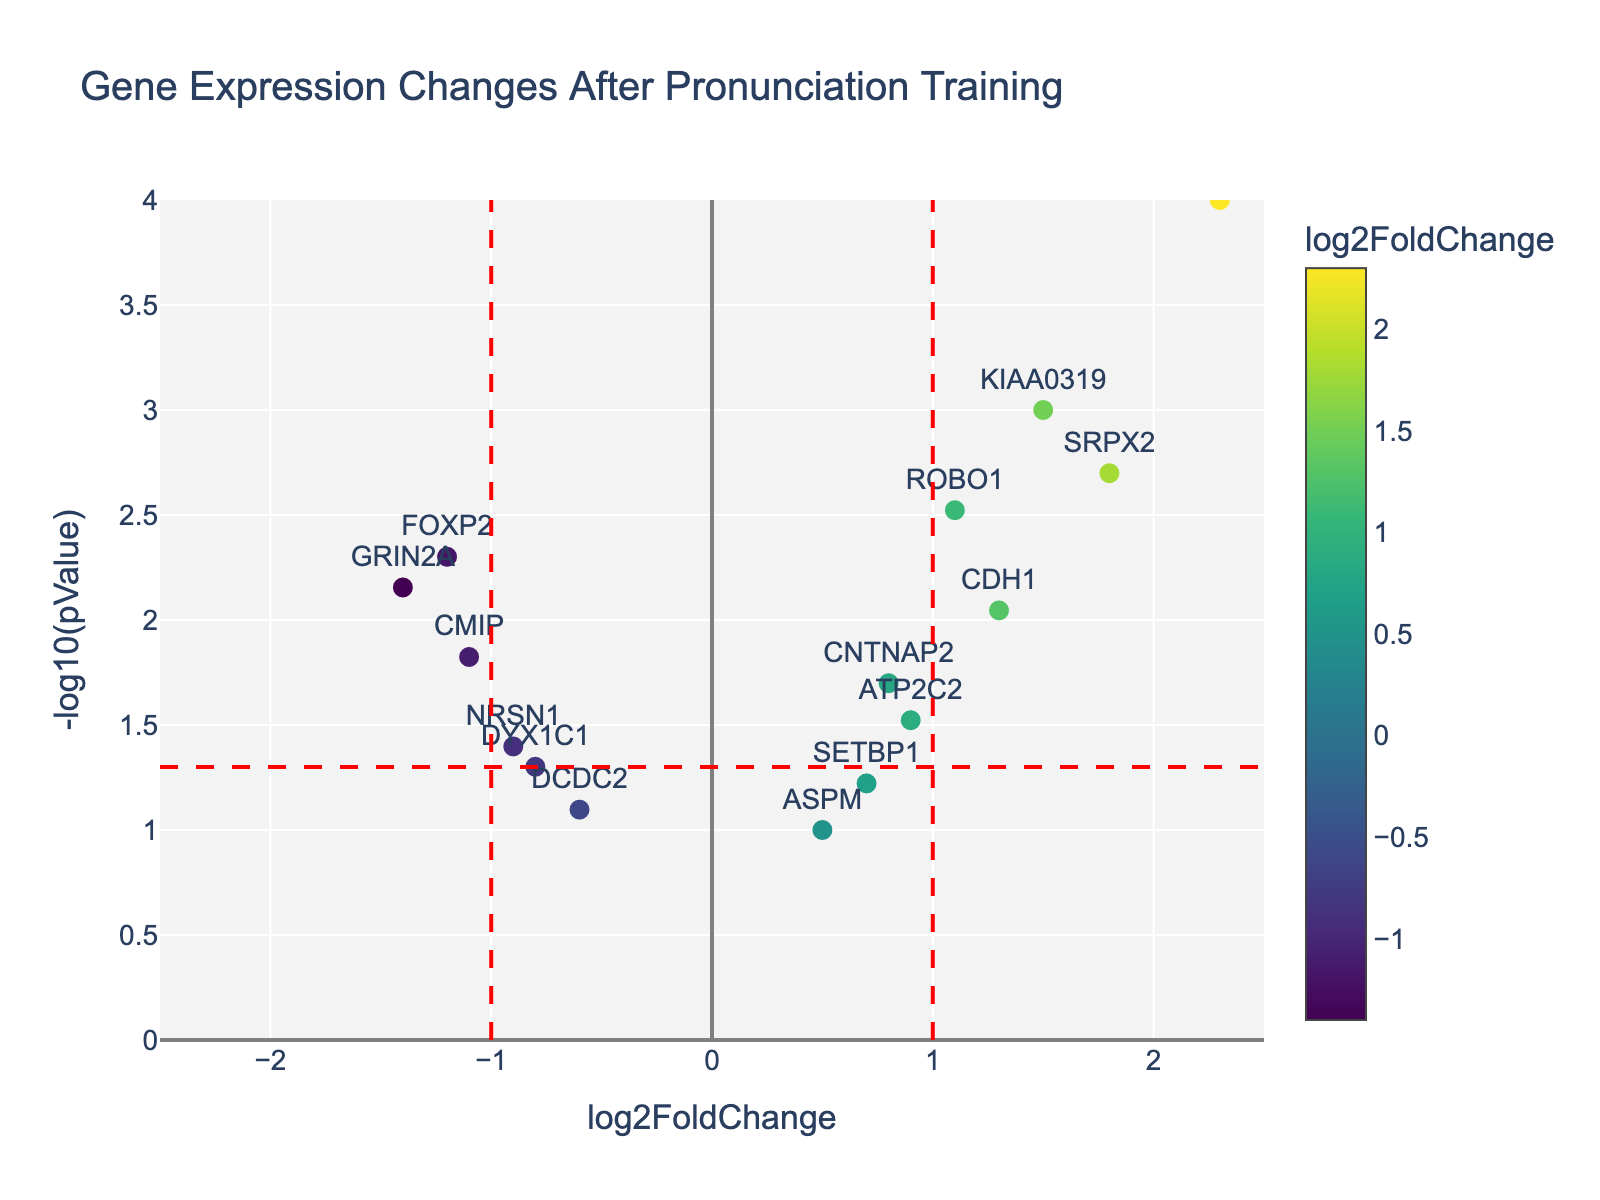How many genes are represented in the plot? Count each unique gene labeled on the plot. There are 15 unique genes shown.
Answer: 15 What does the x-axis represent? The x-axis is labeled 'log2FoldChange,' which indicates the change in gene expression on a log2 scale before and after pronunciation training.
Answer: log2FoldChange Which gene has the highest log2FoldChange? Identify the gene with the highest position on the x-axis. BDNF has the highest log2FoldChange at 2.3.
Answer: BDNF Which genes have a significant p-value below 0.01? Look for genes where the -log10(pValue) is greater than 2, indicating p-values below 0.01. The genes are FOXP2, KIAA0319, ROBO1, SRPX2, GRIN2A, CDH1, and CMIP.
Answer: FOXP2, KIAA0319, ROBO1, SRPX2, GRIN2A, CDH1, CMIP What's the significance threshold for the -log10(pValue)? The horizontal red dashed line intersects the y-axis at 1.3, indicating the threshold for significance.
Answer: 1.3 Which gene shows the largest negative log2FoldChange? Identify the gene with the most leftward position on the x-axis. GRIN2A has the largest negative log2FoldChange at -1.4.
Answer: GRIN2A How many genes have both log2FoldChange values above 1 and significant p-values? Look at genes to the right of the x=1 line and above the y=1.3 line. These genes are KIAA0319, ROBO1, SRPX2, and CDH1.
Answer: 4 Which gene has a log2FoldChange closest to 0.8 and what is its p-value? Look for the gene near the x-axis value of 0.8. The gene is CNTNAP2, which has a p-value of 0.02.
Answer: CNTNAP2, 0.02 What is the p-value range represented in the plot? The range of p-values can be observed from the highest and lowest -log10(pValue) values. The highest -log10(pValue) is 4 (p-value of 0.0001) and the lowest is close to 1 (p-value of 0.1).
Answer: 0.0001 to 0.1 